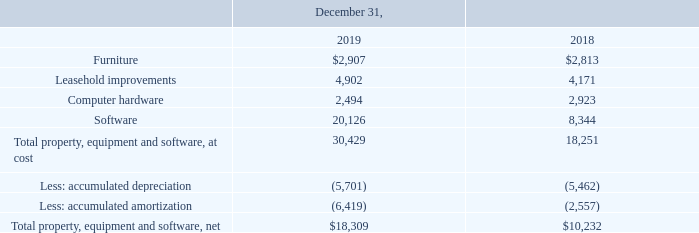GreenSky, Inc. NOTES TO CONSOLIDATED FINANCIAL STATEMENTS — (Continued) (United States Dollars in thousands, except per share data, unless otherwise stated)
Note 6. Property, Equipment and Software
Property, equipment and software were as follows as of the dates indicated.
Which years does the table show? 2019, 2018. What was the amount of Furniture in 2018?
Answer scale should be: thousand. 2,813. What was the amount of Computer hardware in 2019?
Answer scale should be: thousand. 2,494. How many years did Leasehold improvements exceed $4,000 thousand? 2019##2018
Answer: 2. What was the change in the amount of Software between 2018 and 2019?
Answer scale should be: thousand. 20,126-8,344
Answer: 11782. What was the percentage change in the net Total property, equipment and software between 2018 and 2019?
Answer scale should be: percent. (18,309-10,232)/10,232
Answer: 78.94. 